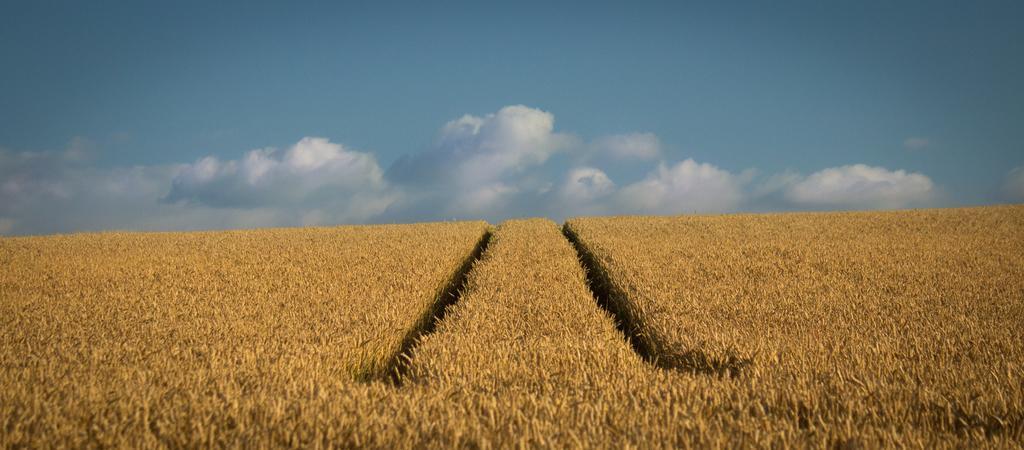Can you describe this image briefly? In this image, we can see a field. There are clouds in the sky. 